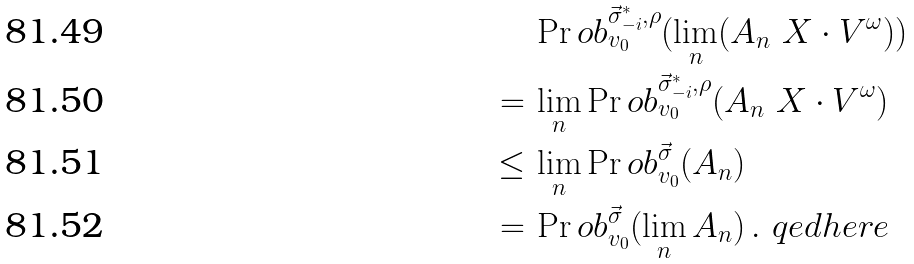Convert formula to latex. <formula><loc_0><loc_0><loc_500><loc_500>& \Pr o b ^ { \vec { \sigma } ^ { * } _ { - i } , \rho } _ { v _ { 0 } } ( \lim _ { n } ( A _ { n } \ X \cdot V ^ { \omega } ) ) \\ = \, & \lim _ { n } \Pr o b ^ { \vec { \sigma } ^ { * } _ { - i } , \rho } _ { v _ { 0 } } ( A _ { n } \ X \cdot V ^ { \omega } ) \\ \leq \, & \lim _ { n } \Pr o b ^ { \vec { \sigma } } _ { v _ { 0 } } ( A _ { n } ) \\ = \, & \Pr o b ^ { \vec { \sigma } } _ { v _ { 0 } } ( \lim _ { n } A _ { n } ) \, . \ q e d h e r e</formula> 